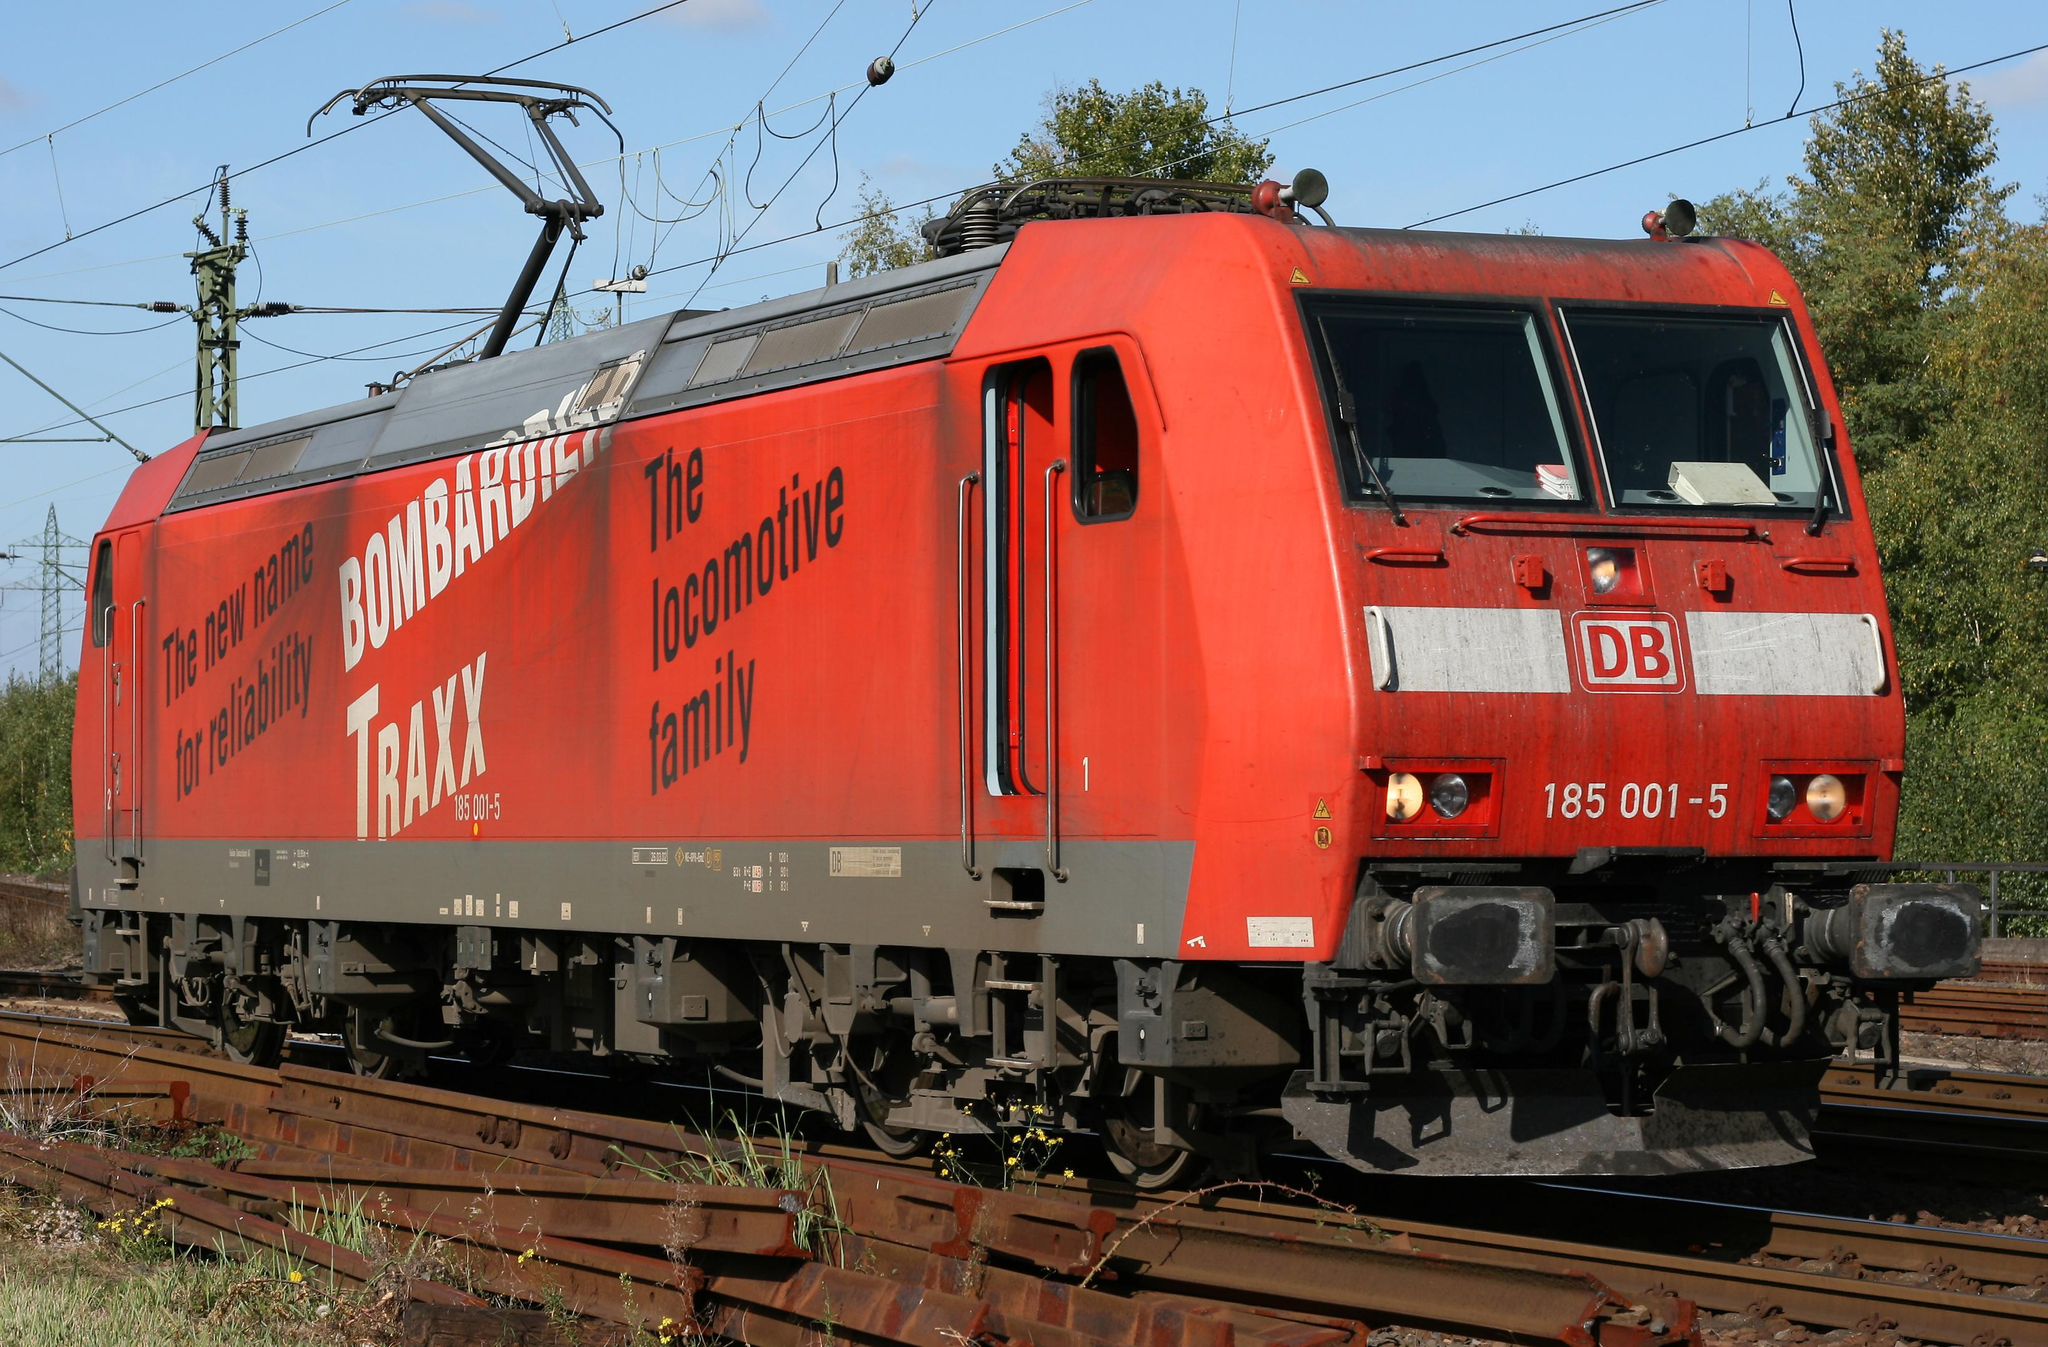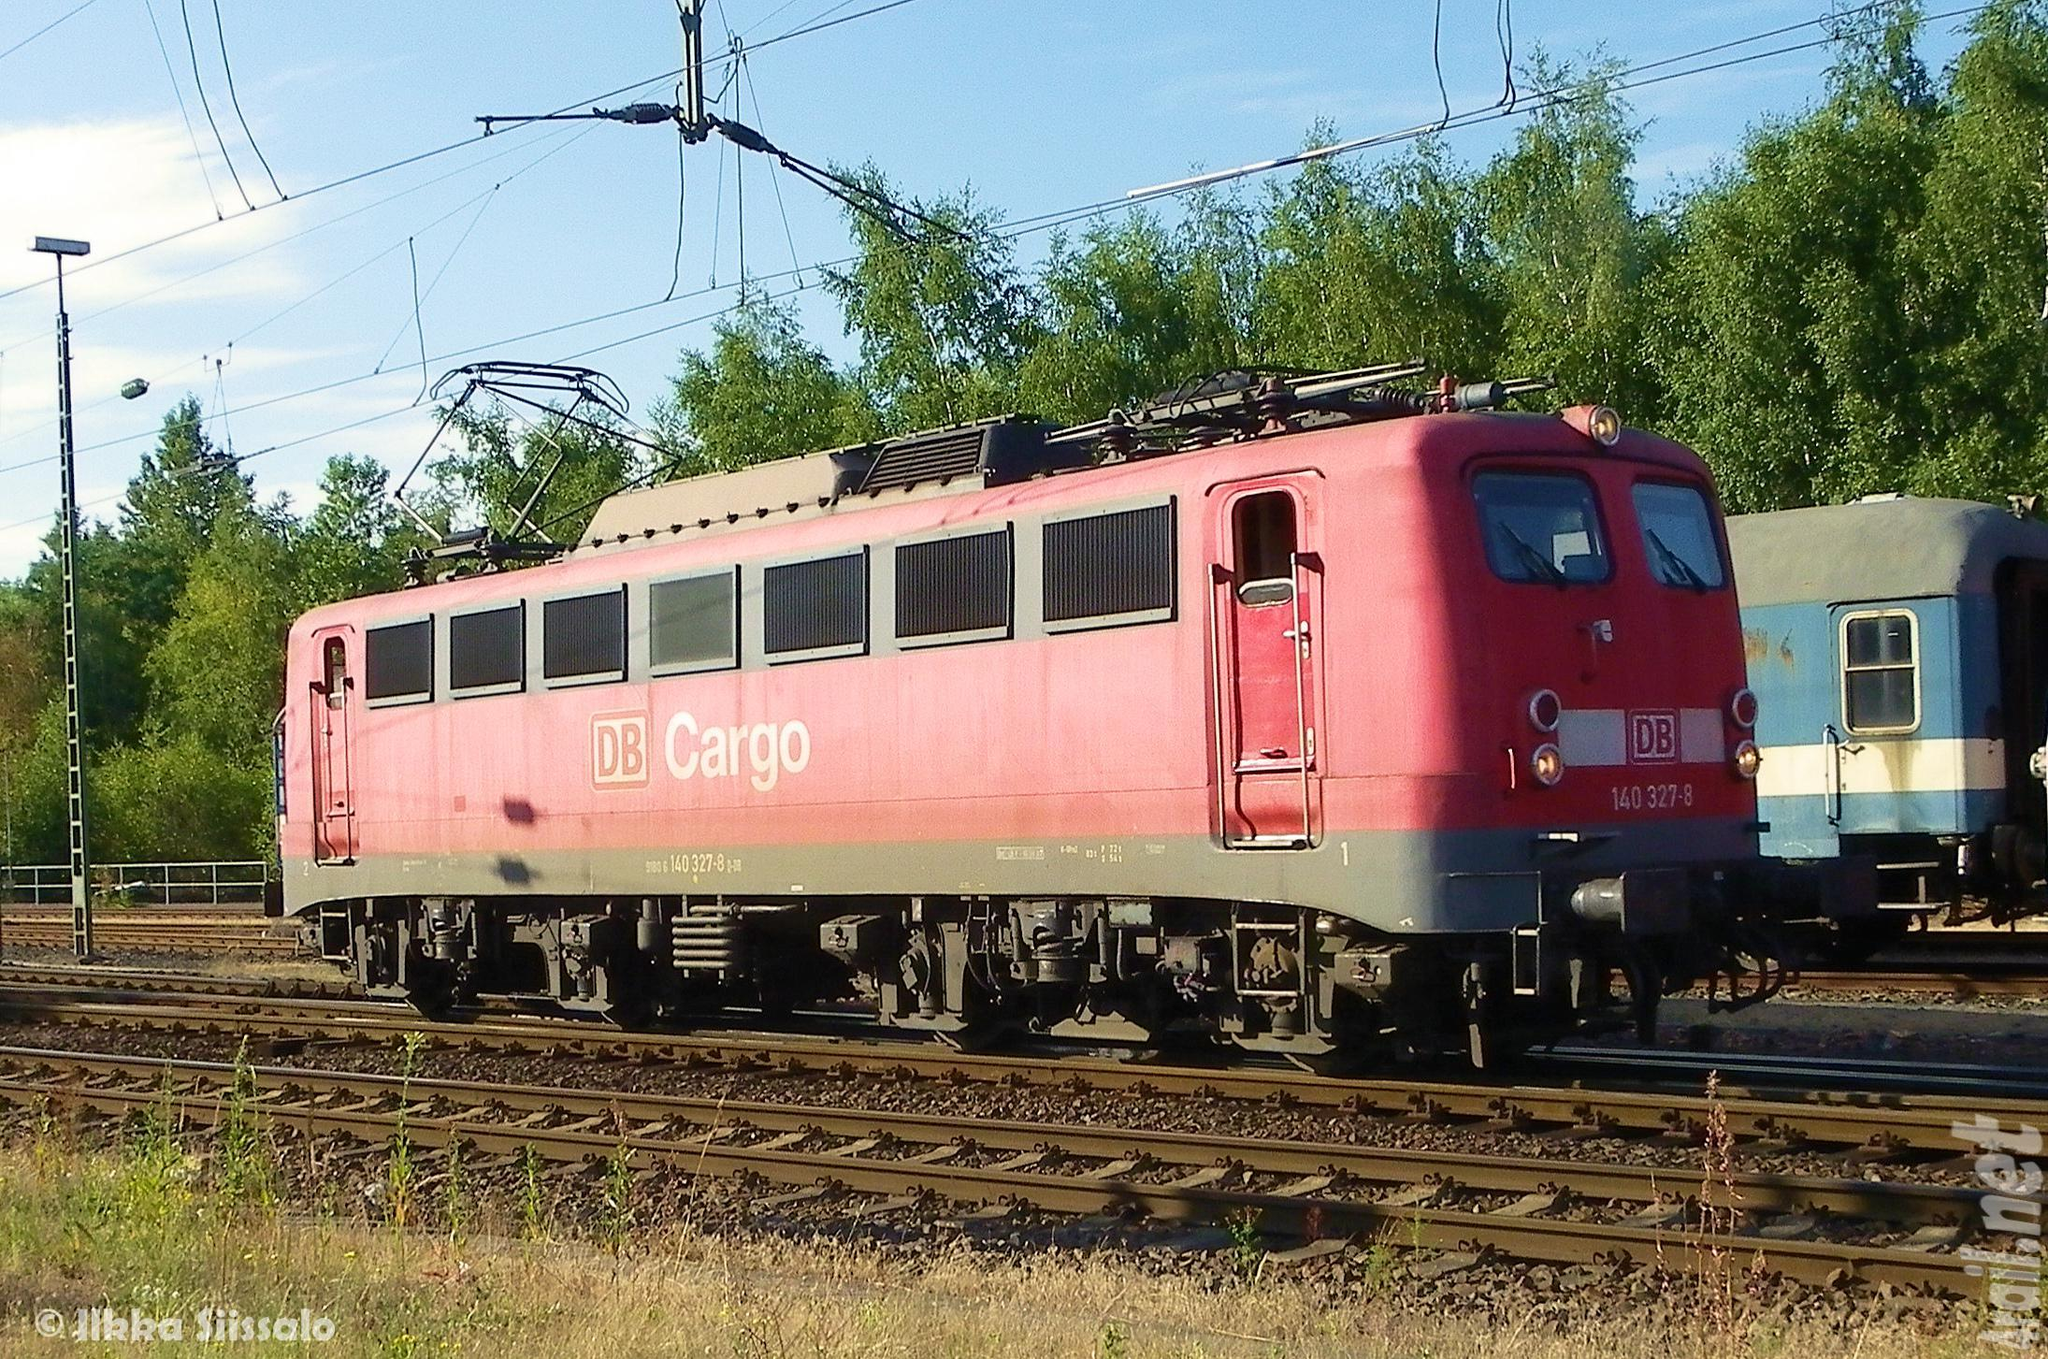The first image is the image on the left, the second image is the image on the right. Analyze the images presented: Is the assertion "All the trains are angled in the same general direction." valid? Answer yes or no. Yes. 